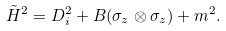Convert formula to latex. <formula><loc_0><loc_0><loc_500><loc_500>\tilde { H } ^ { 2 } = D _ { i } ^ { 2 } + B ( \sigma _ { z } \otimes \sigma _ { z } ) + m ^ { 2 } .</formula> 